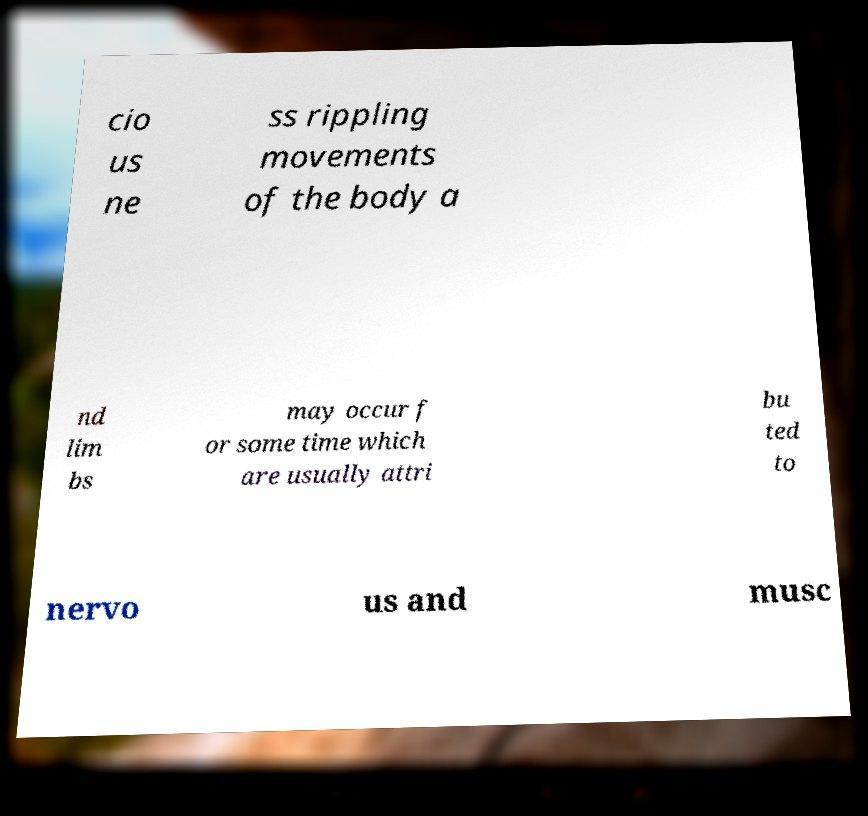For documentation purposes, I need the text within this image transcribed. Could you provide that? cio us ne ss rippling movements of the body a nd lim bs may occur f or some time which are usually attri bu ted to nervo us and musc 